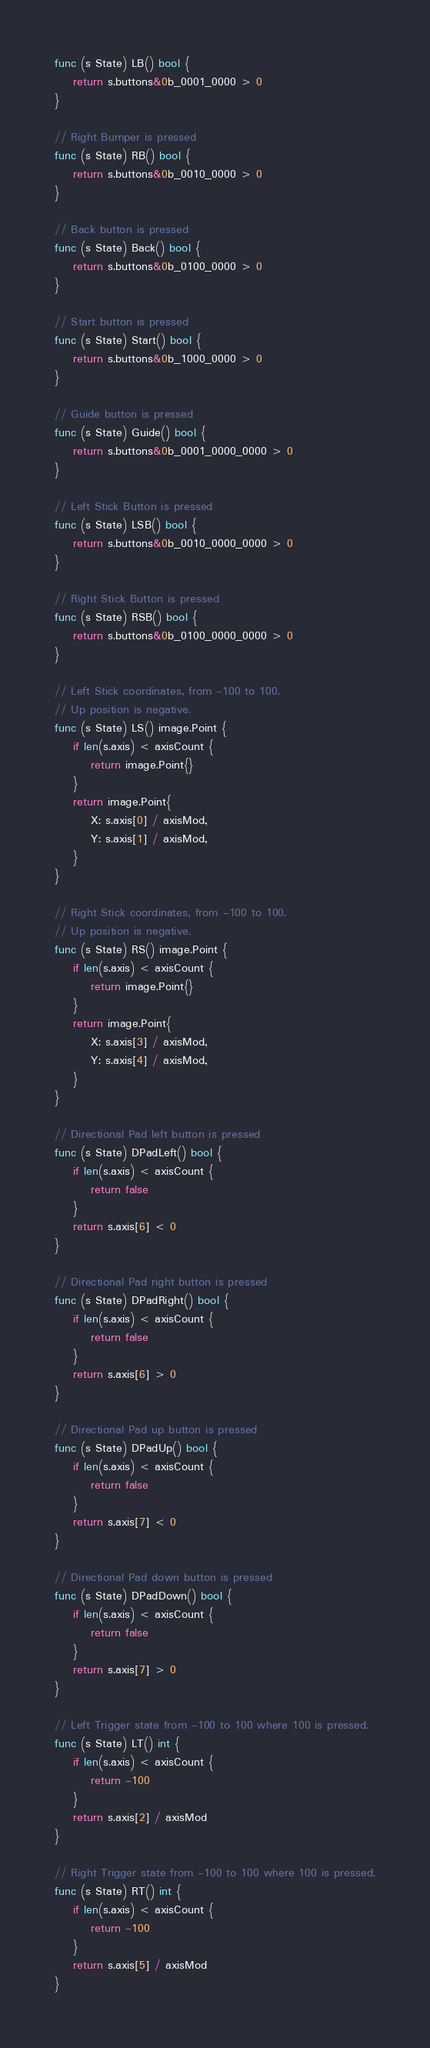<code> <loc_0><loc_0><loc_500><loc_500><_Go_>func (s State) LB() bool {
	return s.buttons&0b_0001_0000 > 0
}

// Right Bumper is pressed
func (s State) RB() bool {
	return s.buttons&0b_0010_0000 > 0
}

// Back button is pressed
func (s State) Back() bool {
	return s.buttons&0b_0100_0000 > 0
}

// Start button is pressed
func (s State) Start() bool {
	return s.buttons&0b_1000_0000 > 0
}

// Guide button is pressed
func (s State) Guide() bool {
	return s.buttons&0b_0001_0000_0000 > 0
}

// Left Stick Button is pressed
func (s State) LSB() bool {
	return s.buttons&0b_0010_0000_0000 > 0
}

// Right Stick Button is pressed
func (s State) RSB() bool {
	return s.buttons&0b_0100_0000_0000 > 0
}

// Left Stick coordinates, from -100 to 100.
// Up position is negative.
func (s State) LS() image.Point {
	if len(s.axis) < axisCount {
		return image.Point{}
	}
	return image.Point{
		X: s.axis[0] / axisMod,
		Y: s.axis[1] / axisMod,
	}
}

// Right Stick coordinates, from -100 to 100.
// Up position is negative.
func (s State) RS() image.Point {
	if len(s.axis) < axisCount {
		return image.Point{}
	}
	return image.Point{
		X: s.axis[3] / axisMod,
		Y: s.axis[4] / axisMod,
	}
}

// Directional Pad left button is pressed
func (s State) DPadLeft() bool {
	if len(s.axis) < axisCount {
		return false
	}
	return s.axis[6] < 0
}

// Directional Pad right button is pressed
func (s State) DPadRight() bool {
	if len(s.axis) < axisCount {
		return false
	}
	return s.axis[6] > 0
}

// Directional Pad up button is pressed
func (s State) DPadUp() bool {
	if len(s.axis) < axisCount {
		return false
	}
	return s.axis[7] < 0
}

// Directional Pad down button is pressed
func (s State) DPadDown() bool {
	if len(s.axis) < axisCount {
		return false
	}
	return s.axis[7] > 0
}

// Left Trigger state from -100 to 100 where 100 is pressed.
func (s State) LT() int {
	if len(s.axis) < axisCount {
		return -100
	}
	return s.axis[2] / axisMod
}

// Right Trigger state from -100 to 100 where 100 is pressed.
func (s State) RT() int {
	if len(s.axis) < axisCount {
		return -100
	}
	return s.axis[5] / axisMod
}
</code> 